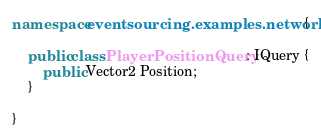Convert code to text. <code><loc_0><loc_0><loc_500><loc_500><_C#_>namespace eventsourcing.examples.network {

    public class PlayerPositionQuery : IQuery {
        public Vector2 Position;
    }

}</code> 